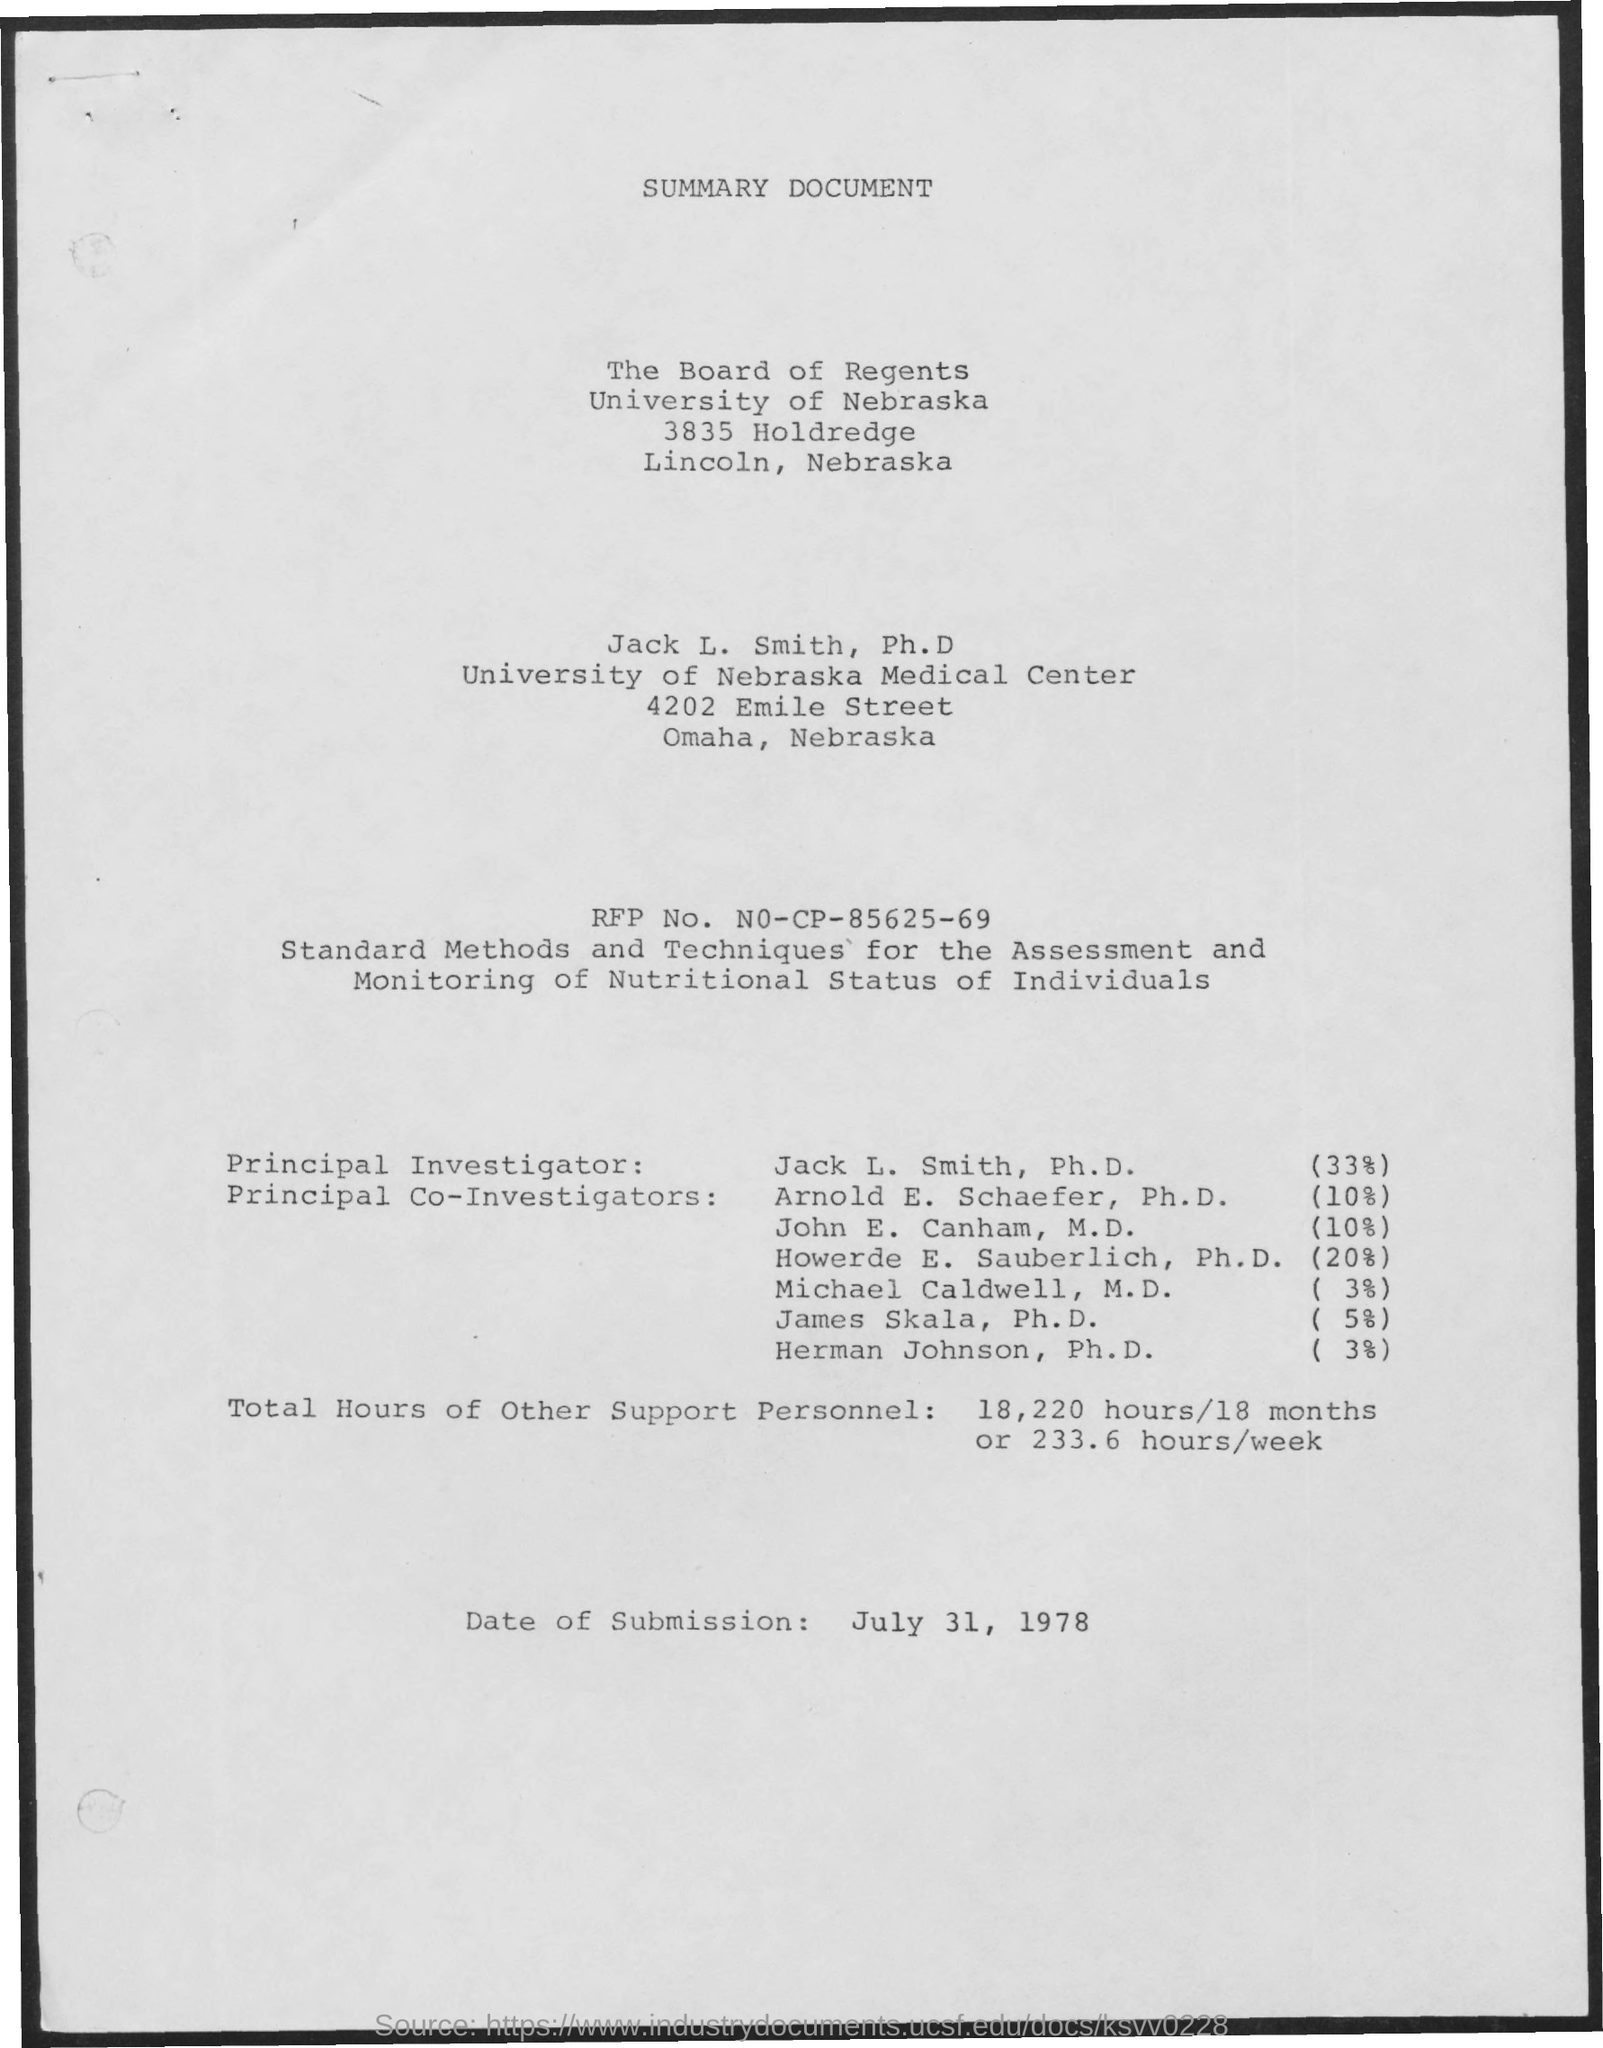What is the RFP No.?
Keep it short and to the point. NO-CP-85625-69. Who is the principal investigator?
Your answer should be compact. Jack L. Smith, Ph.D. How many total hours of other support personnel?
Offer a very short reply. 18,220 HOURS/18 MONTHS OR 233.6 HOURS/WEEK. What is the date of submission?
Provide a short and direct response. JULY 31, 1978. What is the document title?
Provide a short and direct response. SUMMARY DOCUMENT. 